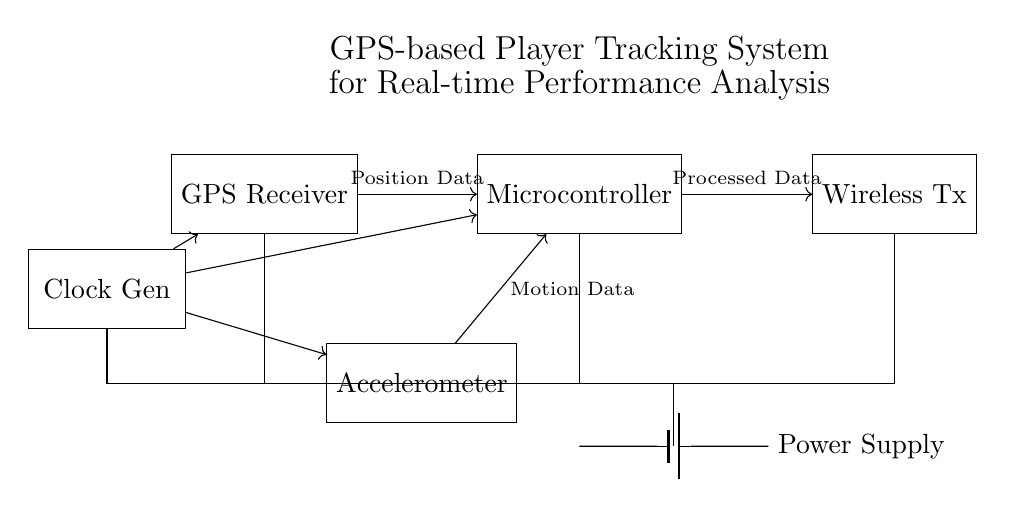What component receives GPS signals? The component that receives GPS signals in the circuit is labeled as "GPS Receiver."
Answer: GPS Receiver What type of data does the accelerometer provide? The accelerometer provides "Motion Data" as indicated in the diagram.
Answer: Motion Data Which component is responsible for processing the data? The "Microcontroller" is responsible for processing the data from both the GPS Receiver and the Accelerometer, as shown by the arrows pointing towards it.
Answer: Microcontroller What is the role of the clock generator in this circuit? The "Clock Generator" supplies timing signals to the GPS Receiver, Accelerometer, and Microcontroller, ensuring synchronized operation.
Answer: Timing signals What kind of connection is used to communicate processed data? The processed data is sent using a "Wireless" connection from the Microcontroller to the Wireless Transmitter in the circuit.
Answer: Wireless connection How many main components are powered by the power supply? There are four main components powered by the power supply: the GPS Receiver, Microcontroller, Accelerometer, and Wireless Transmitter, as depicted in the circuit.
Answer: Four components What type of system is this circuit designed for? This circuit is designed for a "GPS-based Player Tracking System" for real-time performance analysis during training sessions, as stated in the title.
Answer: GPS-based Player Tracking System 